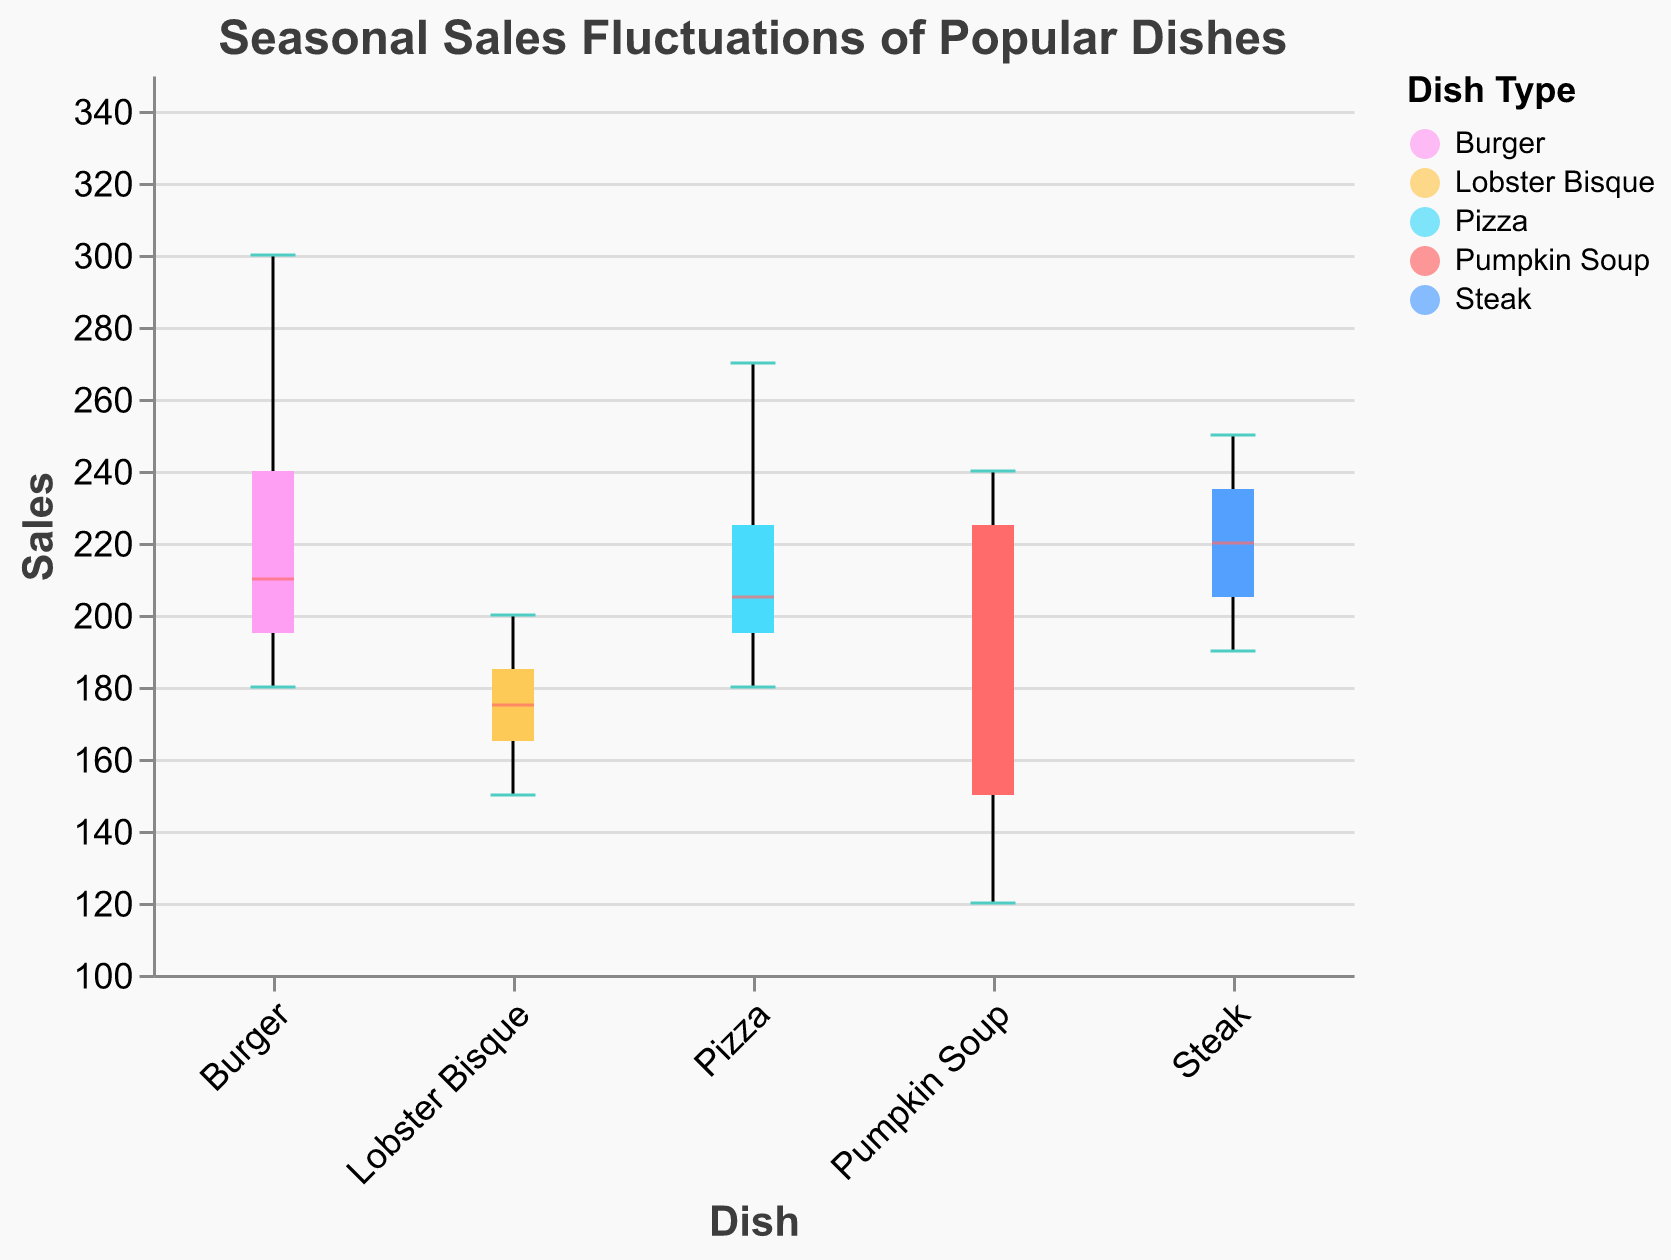What is the title of the box plot? The title is written at the top of the figure. It reads "Seasonal Sales Fluctuations of Popular Dishes".
Answer: Seasonal Sales Fluctuations of Popular Dishes Which dish has the highest median sales value in the summer? To find this, look at the median lines (in color #ff6b6b) for each dish in the summer. The Burger has the highest median sales value.
Answer: Burger During which season does Pumpkin Soup have its lowest sales? Check the position of the lowest whisker (minimum value) for Pumpkin Soup across all seasons. Summer has the lowest sales for Pumpkin Soup.
Answer: Summer What is the range of sales values for Steak in the winter? The range is found by looking at the minimum and maximum whiskers for Steak in winter. The values are between 190 (minimum) and 250 (maximum).
Answer: 190 to 250 Which dish shows the most fluctuation in sales throughout the seasons? The most fluctuation is indicated by the longest whiskers. Burger has the widest range, indicating the most fluctuation in sales.
Answer: Burger How do the median sales of Lobster Bisque in spring compare to fall? Compare the color #ff6b6b median lines for Lobster Bisque in spring and fall. Spring has lower median sales compared to fall.
Answer: Lower What is the difference between the maximum and minimum sales of Pizza in winter? Look at the top and bottom whiskers for Pizza in winter. The maximum is 180 and the minimum is 170, so the difference is 180 - 170.
Answer: 10 How does the median sales of Steak in spring compare with the median sales of Pizza in the same season? Compare the median lines for Steak and Pizza in spring. The median sales of Steak are higher than that of Pizza.
Answer: Higher During which season does Burger have the least fluctuation in sales? Check for the shortest whiskers for Burger across all seasons. Fall has the shortest range, indicating the least fluctuation.
Answer: Fall What is the interquartile range (IQR) of Pumpkin Soup sales for fall? The IQR is the distance between the first quartile and the third quartile. For Pumpkin Soup in fall, the IQR is indicated by the distance within the box. The values range from 210 to 240.
Answer: 30 